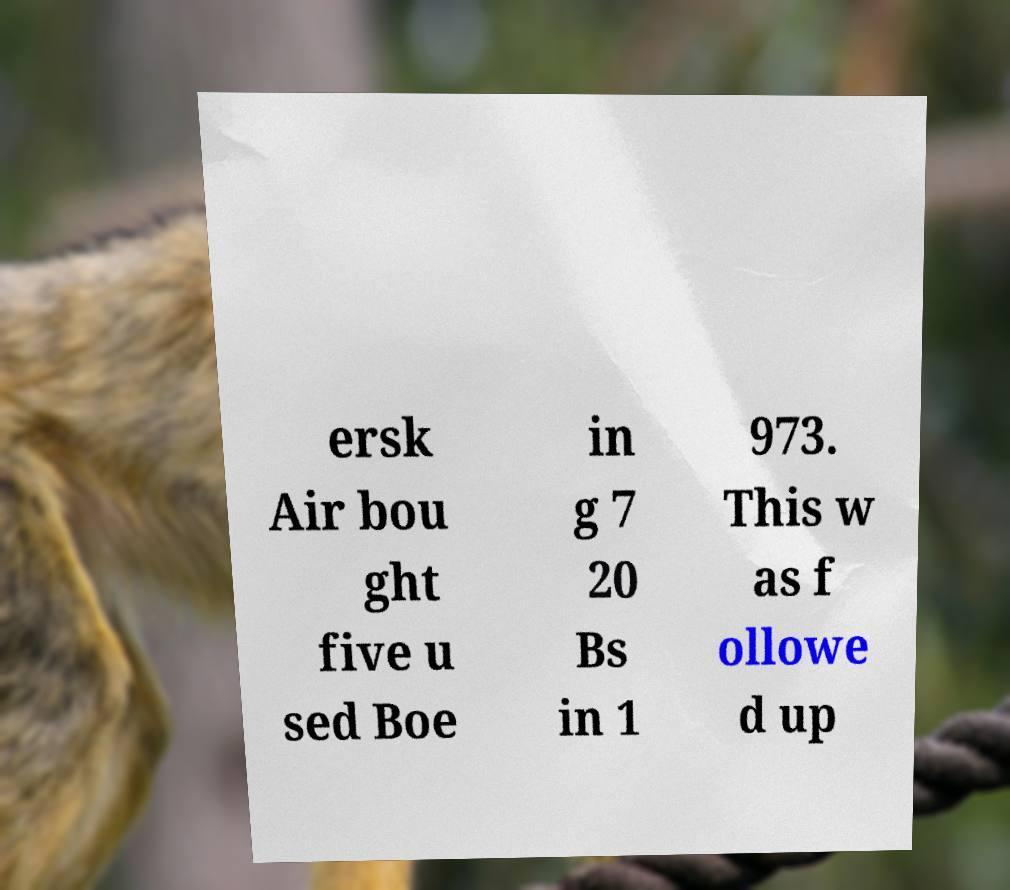Please read and relay the text visible in this image. What does it say? ersk Air bou ght five u sed Boe in g 7 20 Bs in 1 973. This w as f ollowe d up 